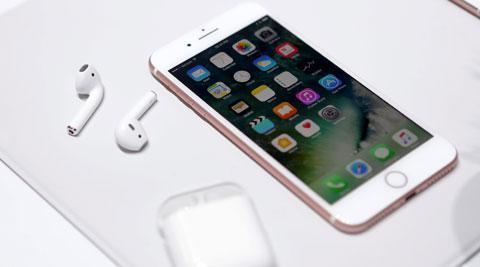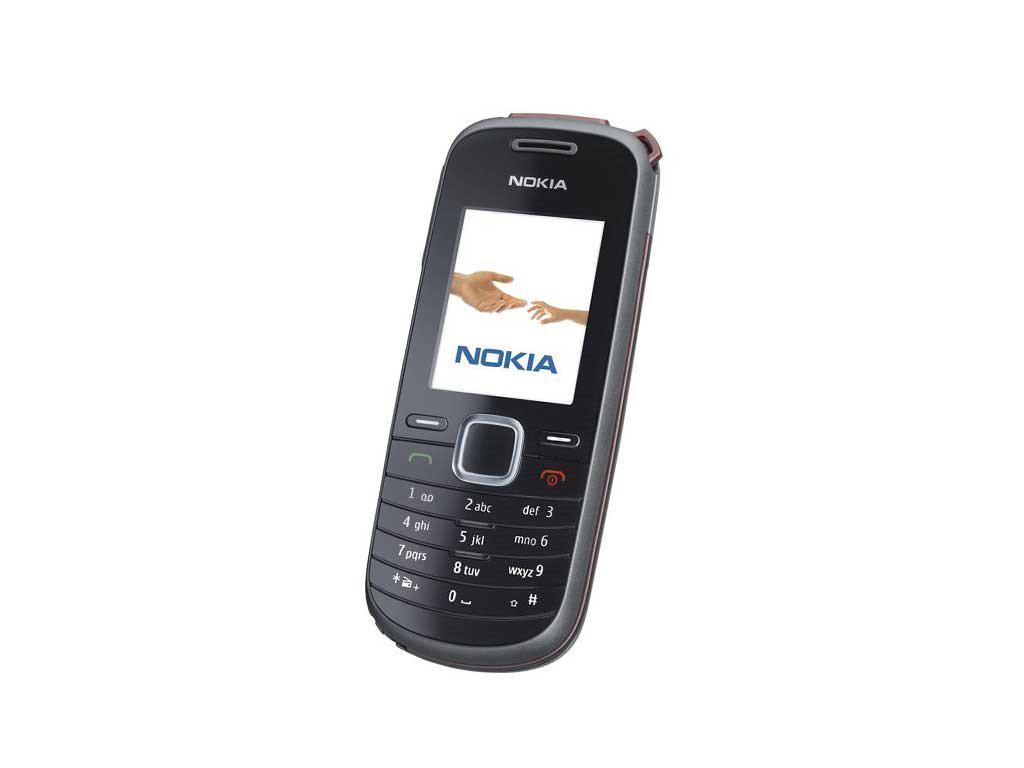The first image is the image on the left, the second image is the image on the right. Considering the images on both sides, is "One phone is white around the screen." valid? Answer yes or no. Yes. The first image is the image on the left, the second image is the image on the right. For the images shown, is this caption "One image shows a flat phone with a big screen displayed head-on and vertically, and the other image includes a phone with an antenna that is displayed at an angle." true? Answer yes or no. No. 